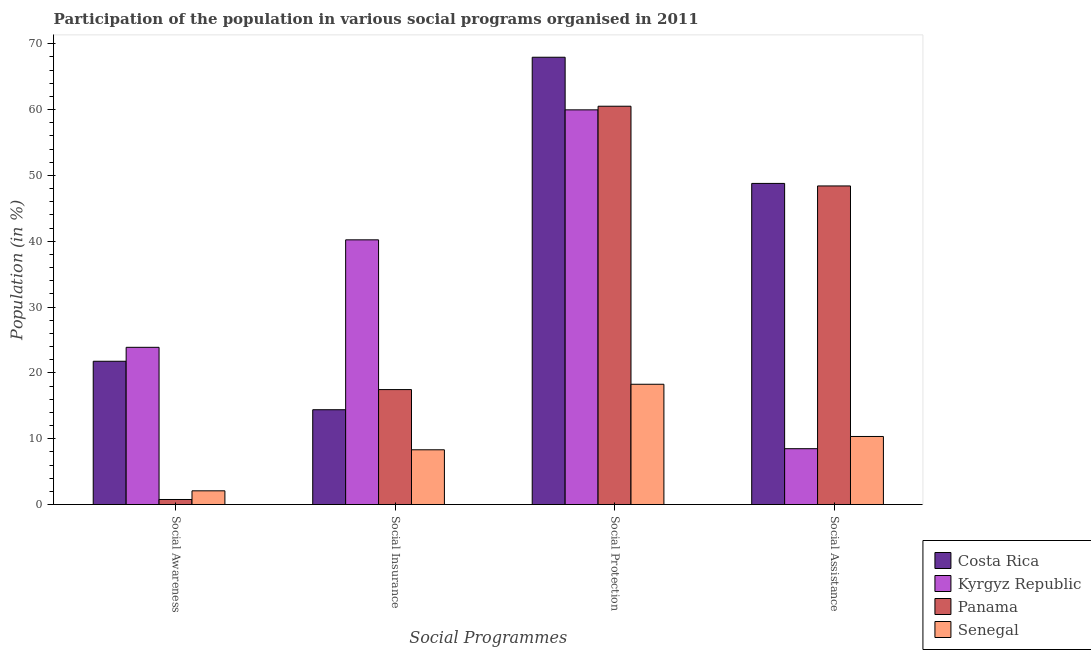How many groups of bars are there?
Keep it short and to the point. 4. Are the number of bars on each tick of the X-axis equal?
Your answer should be very brief. Yes. How many bars are there on the 2nd tick from the left?
Your answer should be very brief. 4. What is the label of the 2nd group of bars from the left?
Your response must be concise. Social Insurance. What is the participation of population in social protection programs in Panama?
Give a very brief answer. 60.5. Across all countries, what is the maximum participation of population in social assistance programs?
Give a very brief answer. 48.78. Across all countries, what is the minimum participation of population in social insurance programs?
Make the answer very short. 8.32. In which country was the participation of population in social awareness programs maximum?
Provide a short and direct response. Kyrgyz Republic. In which country was the participation of population in social protection programs minimum?
Your answer should be very brief. Senegal. What is the total participation of population in social awareness programs in the graph?
Provide a short and direct response. 48.5. What is the difference between the participation of population in social insurance programs in Senegal and that in Kyrgyz Republic?
Make the answer very short. -31.89. What is the difference between the participation of population in social insurance programs in Kyrgyz Republic and the participation of population in social assistance programs in Panama?
Your answer should be compact. -8.19. What is the average participation of population in social assistance programs per country?
Offer a very short reply. 29. What is the difference between the participation of population in social awareness programs and participation of population in social insurance programs in Panama?
Your answer should be compact. -16.7. What is the ratio of the participation of population in social protection programs in Costa Rica to that in Kyrgyz Republic?
Your answer should be compact. 1.13. What is the difference between the highest and the second highest participation of population in social awareness programs?
Your answer should be compact. 2.12. What is the difference between the highest and the lowest participation of population in social awareness programs?
Provide a succinct answer. 23.12. Is it the case that in every country, the sum of the participation of population in social protection programs and participation of population in social insurance programs is greater than the sum of participation of population in social awareness programs and participation of population in social assistance programs?
Keep it short and to the point. No. What does the 3rd bar from the right in Social Assistance represents?
Your answer should be compact. Kyrgyz Republic. Is it the case that in every country, the sum of the participation of population in social awareness programs and participation of population in social insurance programs is greater than the participation of population in social protection programs?
Provide a succinct answer. No. How many countries are there in the graph?
Offer a very short reply. 4. Does the graph contain any zero values?
Ensure brevity in your answer.  No. Where does the legend appear in the graph?
Your answer should be compact. Bottom right. What is the title of the graph?
Provide a short and direct response. Participation of the population in various social programs organised in 2011. Does "Seychelles" appear as one of the legend labels in the graph?
Keep it short and to the point. No. What is the label or title of the X-axis?
Ensure brevity in your answer.  Social Programmes. What is the Population (in %) of Costa Rica in Social Awareness?
Make the answer very short. 21.76. What is the Population (in %) in Kyrgyz Republic in Social Awareness?
Provide a succinct answer. 23.88. What is the Population (in %) of Panama in Social Awareness?
Ensure brevity in your answer.  0.77. What is the Population (in %) in Senegal in Social Awareness?
Your answer should be compact. 2.08. What is the Population (in %) in Costa Rica in Social Insurance?
Offer a terse response. 14.4. What is the Population (in %) in Kyrgyz Republic in Social Insurance?
Your answer should be very brief. 40.21. What is the Population (in %) in Panama in Social Insurance?
Your answer should be very brief. 17.46. What is the Population (in %) in Senegal in Social Insurance?
Your answer should be compact. 8.32. What is the Population (in %) of Costa Rica in Social Protection?
Give a very brief answer. 67.95. What is the Population (in %) of Kyrgyz Republic in Social Protection?
Provide a short and direct response. 59.95. What is the Population (in %) in Panama in Social Protection?
Provide a short and direct response. 60.5. What is the Population (in %) of Senegal in Social Protection?
Your answer should be very brief. 18.27. What is the Population (in %) of Costa Rica in Social Assistance?
Your answer should be very brief. 48.78. What is the Population (in %) of Kyrgyz Republic in Social Assistance?
Your response must be concise. 8.48. What is the Population (in %) in Panama in Social Assistance?
Give a very brief answer. 48.4. What is the Population (in %) of Senegal in Social Assistance?
Provide a short and direct response. 10.34. Across all Social Programmes, what is the maximum Population (in %) in Costa Rica?
Offer a terse response. 67.95. Across all Social Programmes, what is the maximum Population (in %) in Kyrgyz Republic?
Give a very brief answer. 59.95. Across all Social Programmes, what is the maximum Population (in %) in Panama?
Provide a succinct answer. 60.5. Across all Social Programmes, what is the maximum Population (in %) in Senegal?
Your answer should be compact. 18.27. Across all Social Programmes, what is the minimum Population (in %) of Costa Rica?
Offer a very short reply. 14.4. Across all Social Programmes, what is the minimum Population (in %) in Kyrgyz Republic?
Provide a short and direct response. 8.48. Across all Social Programmes, what is the minimum Population (in %) of Panama?
Offer a very short reply. 0.77. Across all Social Programmes, what is the minimum Population (in %) in Senegal?
Your answer should be very brief. 2.08. What is the total Population (in %) in Costa Rica in the graph?
Your answer should be very brief. 152.89. What is the total Population (in %) of Kyrgyz Republic in the graph?
Keep it short and to the point. 132.53. What is the total Population (in %) of Panama in the graph?
Give a very brief answer. 127.13. What is the total Population (in %) of Senegal in the graph?
Provide a short and direct response. 39.01. What is the difference between the Population (in %) of Costa Rica in Social Awareness and that in Social Insurance?
Your answer should be very brief. 7.36. What is the difference between the Population (in %) of Kyrgyz Republic in Social Awareness and that in Social Insurance?
Offer a terse response. -16.33. What is the difference between the Population (in %) in Panama in Social Awareness and that in Social Insurance?
Your response must be concise. -16.7. What is the difference between the Population (in %) in Senegal in Social Awareness and that in Social Insurance?
Provide a succinct answer. -6.23. What is the difference between the Population (in %) of Costa Rica in Social Awareness and that in Social Protection?
Your answer should be very brief. -46.18. What is the difference between the Population (in %) in Kyrgyz Republic in Social Awareness and that in Social Protection?
Give a very brief answer. -36.07. What is the difference between the Population (in %) in Panama in Social Awareness and that in Social Protection?
Make the answer very short. -59.74. What is the difference between the Population (in %) of Senegal in Social Awareness and that in Social Protection?
Your response must be concise. -16.19. What is the difference between the Population (in %) in Costa Rica in Social Awareness and that in Social Assistance?
Make the answer very short. -27.02. What is the difference between the Population (in %) of Kyrgyz Republic in Social Awareness and that in Social Assistance?
Keep it short and to the point. 15.4. What is the difference between the Population (in %) of Panama in Social Awareness and that in Social Assistance?
Give a very brief answer. -47.63. What is the difference between the Population (in %) of Senegal in Social Awareness and that in Social Assistance?
Your answer should be compact. -8.26. What is the difference between the Population (in %) in Costa Rica in Social Insurance and that in Social Protection?
Provide a short and direct response. -53.54. What is the difference between the Population (in %) of Kyrgyz Republic in Social Insurance and that in Social Protection?
Your answer should be compact. -19.75. What is the difference between the Population (in %) of Panama in Social Insurance and that in Social Protection?
Make the answer very short. -43.04. What is the difference between the Population (in %) in Senegal in Social Insurance and that in Social Protection?
Keep it short and to the point. -9.95. What is the difference between the Population (in %) of Costa Rica in Social Insurance and that in Social Assistance?
Offer a terse response. -34.38. What is the difference between the Population (in %) in Kyrgyz Republic in Social Insurance and that in Social Assistance?
Provide a short and direct response. 31.73. What is the difference between the Population (in %) of Panama in Social Insurance and that in Social Assistance?
Provide a short and direct response. -30.93. What is the difference between the Population (in %) of Senegal in Social Insurance and that in Social Assistance?
Make the answer very short. -2.02. What is the difference between the Population (in %) of Costa Rica in Social Protection and that in Social Assistance?
Your answer should be very brief. 19.17. What is the difference between the Population (in %) of Kyrgyz Republic in Social Protection and that in Social Assistance?
Your answer should be compact. 51.47. What is the difference between the Population (in %) in Panama in Social Protection and that in Social Assistance?
Your response must be concise. 12.11. What is the difference between the Population (in %) in Senegal in Social Protection and that in Social Assistance?
Offer a terse response. 7.93. What is the difference between the Population (in %) in Costa Rica in Social Awareness and the Population (in %) in Kyrgyz Republic in Social Insurance?
Offer a very short reply. -18.44. What is the difference between the Population (in %) in Costa Rica in Social Awareness and the Population (in %) in Panama in Social Insurance?
Your answer should be compact. 4.3. What is the difference between the Population (in %) of Costa Rica in Social Awareness and the Population (in %) of Senegal in Social Insurance?
Provide a short and direct response. 13.45. What is the difference between the Population (in %) of Kyrgyz Republic in Social Awareness and the Population (in %) of Panama in Social Insurance?
Offer a very short reply. 6.42. What is the difference between the Population (in %) in Kyrgyz Republic in Social Awareness and the Population (in %) in Senegal in Social Insurance?
Keep it short and to the point. 15.57. What is the difference between the Population (in %) of Panama in Social Awareness and the Population (in %) of Senegal in Social Insurance?
Provide a short and direct response. -7.55. What is the difference between the Population (in %) in Costa Rica in Social Awareness and the Population (in %) in Kyrgyz Republic in Social Protection?
Ensure brevity in your answer.  -38.19. What is the difference between the Population (in %) of Costa Rica in Social Awareness and the Population (in %) of Panama in Social Protection?
Your answer should be compact. -38.74. What is the difference between the Population (in %) of Costa Rica in Social Awareness and the Population (in %) of Senegal in Social Protection?
Offer a very short reply. 3.49. What is the difference between the Population (in %) of Kyrgyz Republic in Social Awareness and the Population (in %) of Panama in Social Protection?
Your answer should be very brief. -36.62. What is the difference between the Population (in %) of Kyrgyz Republic in Social Awareness and the Population (in %) of Senegal in Social Protection?
Ensure brevity in your answer.  5.61. What is the difference between the Population (in %) of Panama in Social Awareness and the Population (in %) of Senegal in Social Protection?
Provide a succinct answer. -17.5. What is the difference between the Population (in %) of Costa Rica in Social Awareness and the Population (in %) of Kyrgyz Republic in Social Assistance?
Keep it short and to the point. 13.28. What is the difference between the Population (in %) in Costa Rica in Social Awareness and the Population (in %) in Panama in Social Assistance?
Provide a short and direct response. -26.63. What is the difference between the Population (in %) in Costa Rica in Social Awareness and the Population (in %) in Senegal in Social Assistance?
Your response must be concise. 11.42. What is the difference between the Population (in %) in Kyrgyz Republic in Social Awareness and the Population (in %) in Panama in Social Assistance?
Provide a succinct answer. -24.51. What is the difference between the Population (in %) of Kyrgyz Republic in Social Awareness and the Population (in %) of Senegal in Social Assistance?
Keep it short and to the point. 13.54. What is the difference between the Population (in %) in Panama in Social Awareness and the Population (in %) in Senegal in Social Assistance?
Your answer should be compact. -9.57. What is the difference between the Population (in %) of Costa Rica in Social Insurance and the Population (in %) of Kyrgyz Republic in Social Protection?
Your answer should be very brief. -45.55. What is the difference between the Population (in %) in Costa Rica in Social Insurance and the Population (in %) in Panama in Social Protection?
Keep it short and to the point. -46.1. What is the difference between the Population (in %) in Costa Rica in Social Insurance and the Population (in %) in Senegal in Social Protection?
Your answer should be very brief. -3.87. What is the difference between the Population (in %) in Kyrgyz Republic in Social Insurance and the Population (in %) in Panama in Social Protection?
Offer a very short reply. -20.29. What is the difference between the Population (in %) of Kyrgyz Republic in Social Insurance and the Population (in %) of Senegal in Social Protection?
Offer a terse response. 21.94. What is the difference between the Population (in %) in Panama in Social Insurance and the Population (in %) in Senegal in Social Protection?
Make the answer very short. -0.81. What is the difference between the Population (in %) of Costa Rica in Social Insurance and the Population (in %) of Kyrgyz Republic in Social Assistance?
Make the answer very short. 5.92. What is the difference between the Population (in %) in Costa Rica in Social Insurance and the Population (in %) in Panama in Social Assistance?
Offer a very short reply. -33.99. What is the difference between the Population (in %) in Costa Rica in Social Insurance and the Population (in %) in Senegal in Social Assistance?
Offer a very short reply. 4.06. What is the difference between the Population (in %) in Kyrgyz Republic in Social Insurance and the Population (in %) in Panama in Social Assistance?
Make the answer very short. -8.19. What is the difference between the Population (in %) in Kyrgyz Republic in Social Insurance and the Population (in %) in Senegal in Social Assistance?
Ensure brevity in your answer.  29.87. What is the difference between the Population (in %) in Panama in Social Insurance and the Population (in %) in Senegal in Social Assistance?
Your answer should be compact. 7.12. What is the difference between the Population (in %) in Costa Rica in Social Protection and the Population (in %) in Kyrgyz Republic in Social Assistance?
Offer a terse response. 59.46. What is the difference between the Population (in %) of Costa Rica in Social Protection and the Population (in %) of Panama in Social Assistance?
Your answer should be very brief. 19.55. What is the difference between the Population (in %) of Costa Rica in Social Protection and the Population (in %) of Senegal in Social Assistance?
Make the answer very short. 57.61. What is the difference between the Population (in %) in Kyrgyz Republic in Social Protection and the Population (in %) in Panama in Social Assistance?
Offer a terse response. 11.56. What is the difference between the Population (in %) of Kyrgyz Republic in Social Protection and the Population (in %) of Senegal in Social Assistance?
Provide a succinct answer. 49.61. What is the difference between the Population (in %) in Panama in Social Protection and the Population (in %) in Senegal in Social Assistance?
Provide a succinct answer. 50.16. What is the average Population (in %) of Costa Rica per Social Programmes?
Keep it short and to the point. 38.22. What is the average Population (in %) in Kyrgyz Republic per Social Programmes?
Ensure brevity in your answer.  33.13. What is the average Population (in %) in Panama per Social Programmes?
Give a very brief answer. 31.78. What is the average Population (in %) of Senegal per Social Programmes?
Your answer should be compact. 9.75. What is the difference between the Population (in %) of Costa Rica and Population (in %) of Kyrgyz Republic in Social Awareness?
Offer a terse response. -2.12. What is the difference between the Population (in %) in Costa Rica and Population (in %) in Panama in Social Awareness?
Your answer should be very brief. 21. What is the difference between the Population (in %) of Costa Rica and Population (in %) of Senegal in Social Awareness?
Give a very brief answer. 19.68. What is the difference between the Population (in %) of Kyrgyz Republic and Population (in %) of Panama in Social Awareness?
Keep it short and to the point. 23.12. What is the difference between the Population (in %) in Kyrgyz Republic and Population (in %) in Senegal in Social Awareness?
Your response must be concise. 21.8. What is the difference between the Population (in %) of Panama and Population (in %) of Senegal in Social Awareness?
Give a very brief answer. -1.32. What is the difference between the Population (in %) in Costa Rica and Population (in %) in Kyrgyz Republic in Social Insurance?
Make the answer very short. -25.81. What is the difference between the Population (in %) in Costa Rica and Population (in %) in Panama in Social Insurance?
Your answer should be compact. -3.06. What is the difference between the Population (in %) in Costa Rica and Population (in %) in Senegal in Social Insurance?
Give a very brief answer. 6.09. What is the difference between the Population (in %) in Kyrgyz Republic and Population (in %) in Panama in Social Insurance?
Your answer should be compact. 22.75. What is the difference between the Population (in %) in Kyrgyz Republic and Population (in %) in Senegal in Social Insurance?
Your response must be concise. 31.89. What is the difference between the Population (in %) in Panama and Population (in %) in Senegal in Social Insurance?
Provide a succinct answer. 9.14. What is the difference between the Population (in %) in Costa Rica and Population (in %) in Kyrgyz Republic in Social Protection?
Provide a succinct answer. 7.99. What is the difference between the Population (in %) in Costa Rica and Population (in %) in Panama in Social Protection?
Make the answer very short. 7.44. What is the difference between the Population (in %) in Costa Rica and Population (in %) in Senegal in Social Protection?
Offer a terse response. 49.67. What is the difference between the Population (in %) of Kyrgyz Republic and Population (in %) of Panama in Social Protection?
Your answer should be compact. -0.55. What is the difference between the Population (in %) in Kyrgyz Republic and Population (in %) in Senegal in Social Protection?
Ensure brevity in your answer.  41.68. What is the difference between the Population (in %) in Panama and Population (in %) in Senegal in Social Protection?
Provide a short and direct response. 42.23. What is the difference between the Population (in %) of Costa Rica and Population (in %) of Kyrgyz Republic in Social Assistance?
Provide a short and direct response. 40.3. What is the difference between the Population (in %) in Costa Rica and Population (in %) in Panama in Social Assistance?
Provide a short and direct response. 0.38. What is the difference between the Population (in %) of Costa Rica and Population (in %) of Senegal in Social Assistance?
Ensure brevity in your answer.  38.44. What is the difference between the Population (in %) of Kyrgyz Republic and Population (in %) of Panama in Social Assistance?
Provide a succinct answer. -39.91. What is the difference between the Population (in %) of Kyrgyz Republic and Population (in %) of Senegal in Social Assistance?
Your response must be concise. -1.86. What is the difference between the Population (in %) of Panama and Population (in %) of Senegal in Social Assistance?
Offer a terse response. 38.06. What is the ratio of the Population (in %) of Costa Rica in Social Awareness to that in Social Insurance?
Offer a terse response. 1.51. What is the ratio of the Population (in %) in Kyrgyz Republic in Social Awareness to that in Social Insurance?
Give a very brief answer. 0.59. What is the ratio of the Population (in %) in Panama in Social Awareness to that in Social Insurance?
Make the answer very short. 0.04. What is the ratio of the Population (in %) in Senegal in Social Awareness to that in Social Insurance?
Make the answer very short. 0.25. What is the ratio of the Population (in %) of Costa Rica in Social Awareness to that in Social Protection?
Provide a succinct answer. 0.32. What is the ratio of the Population (in %) of Kyrgyz Republic in Social Awareness to that in Social Protection?
Ensure brevity in your answer.  0.4. What is the ratio of the Population (in %) in Panama in Social Awareness to that in Social Protection?
Provide a succinct answer. 0.01. What is the ratio of the Population (in %) of Senegal in Social Awareness to that in Social Protection?
Ensure brevity in your answer.  0.11. What is the ratio of the Population (in %) of Costa Rica in Social Awareness to that in Social Assistance?
Your response must be concise. 0.45. What is the ratio of the Population (in %) of Kyrgyz Republic in Social Awareness to that in Social Assistance?
Provide a short and direct response. 2.82. What is the ratio of the Population (in %) in Panama in Social Awareness to that in Social Assistance?
Ensure brevity in your answer.  0.02. What is the ratio of the Population (in %) in Senegal in Social Awareness to that in Social Assistance?
Offer a terse response. 0.2. What is the ratio of the Population (in %) of Costa Rica in Social Insurance to that in Social Protection?
Offer a very short reply. 0.21. What is the ratio of the Population (in %) of Kyrgyz Republic in Social Insurance to that in Social Protection?
Give a very brief answer. 0.67. What is the ratio of the Population (in %) of Panama in Social Insurance to that in Social Protection?
Ensure brevity in your answer.  0.29. What is the ratio of the Population (in %) in Senegal in Social Insurance to that in Social Protection?
Offer a terse response. 0.46. What is the ratio of the Population (in %) in Costa Rica in Social Insurance to that in Social Assistance?
Offer a terse response. 0.3. What is the ratio of the Population (in %) of Kyrgyz Republic in Social Insurance to that in Social Assistance?
Offer a terse response. 4.74. What is the ratio of the Population (in %) of Panama in Social Insurance to that in Social Assistance?
Offer a terse response. 0.36. What is the ratio of the Population (in %) of Senegal in Social Insurance to that in Social Assistance?
Your answer should be compact. 0.8. What is the ratio of the Population (in %) of Costa Rica in Social Protection to that in Social Assistance?
Keep it short and to the point. 1.39. What is the ratio of the Population (in %) in Kyrgyz Republic in Social Protection to that in Social Assistance?
Your answer should be very brief. 7.07. What is the ratio of the Population (in %) in Panama in Social Protection to that in Social Assistance?
Ensure brevity in your answer.  1.25. What is the ratio of the Population (in %) of Senegal in Social Protection to that in Social Assistance?
Give a very brief answer. 1.77. What is the difference between the highest and the second highest Population (in %) in Costa Rica?
Your answer should be compact. 19.17. What is the difference between the highest and the second highest Population (in %) in Kyrgyz Republic?
Make the answer very short. 19.75. What is the difference between the highest and the second highest Population (in %) in Panama?
Provide a succinct answer. 12.11. What is the difference between the highest and the second highest Population (in %) in Senegal?
Make the answer very short. 7.93. What is the difference between the highest and the lowest Population (in %) in Costa Rica?
Ensure brevity in your answer.  53.54. What is the difference between the highest and the lowest Population (in %) of Kyrgyz Republic?
Your response must be concise. 51.47. What is the difference between the highest and the lowest Population (in %) of Panama?
Offer a terse response. 59.74. What is the difference between the highest and the lowest Population (in %) of Senegal?
Make the answer very short. 16.19. 